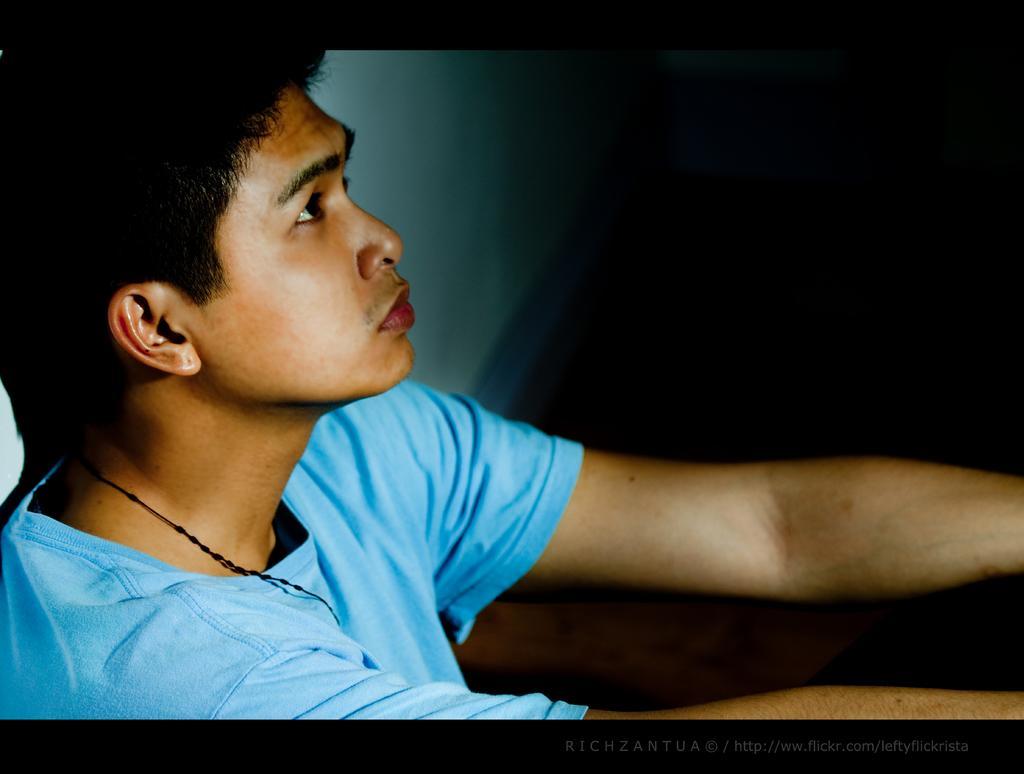In one or two sentences, can you explain what this image depicts? This is a close up image of a man wearing blue T-shirt. This is a wall and the right side background of the image is dark. 